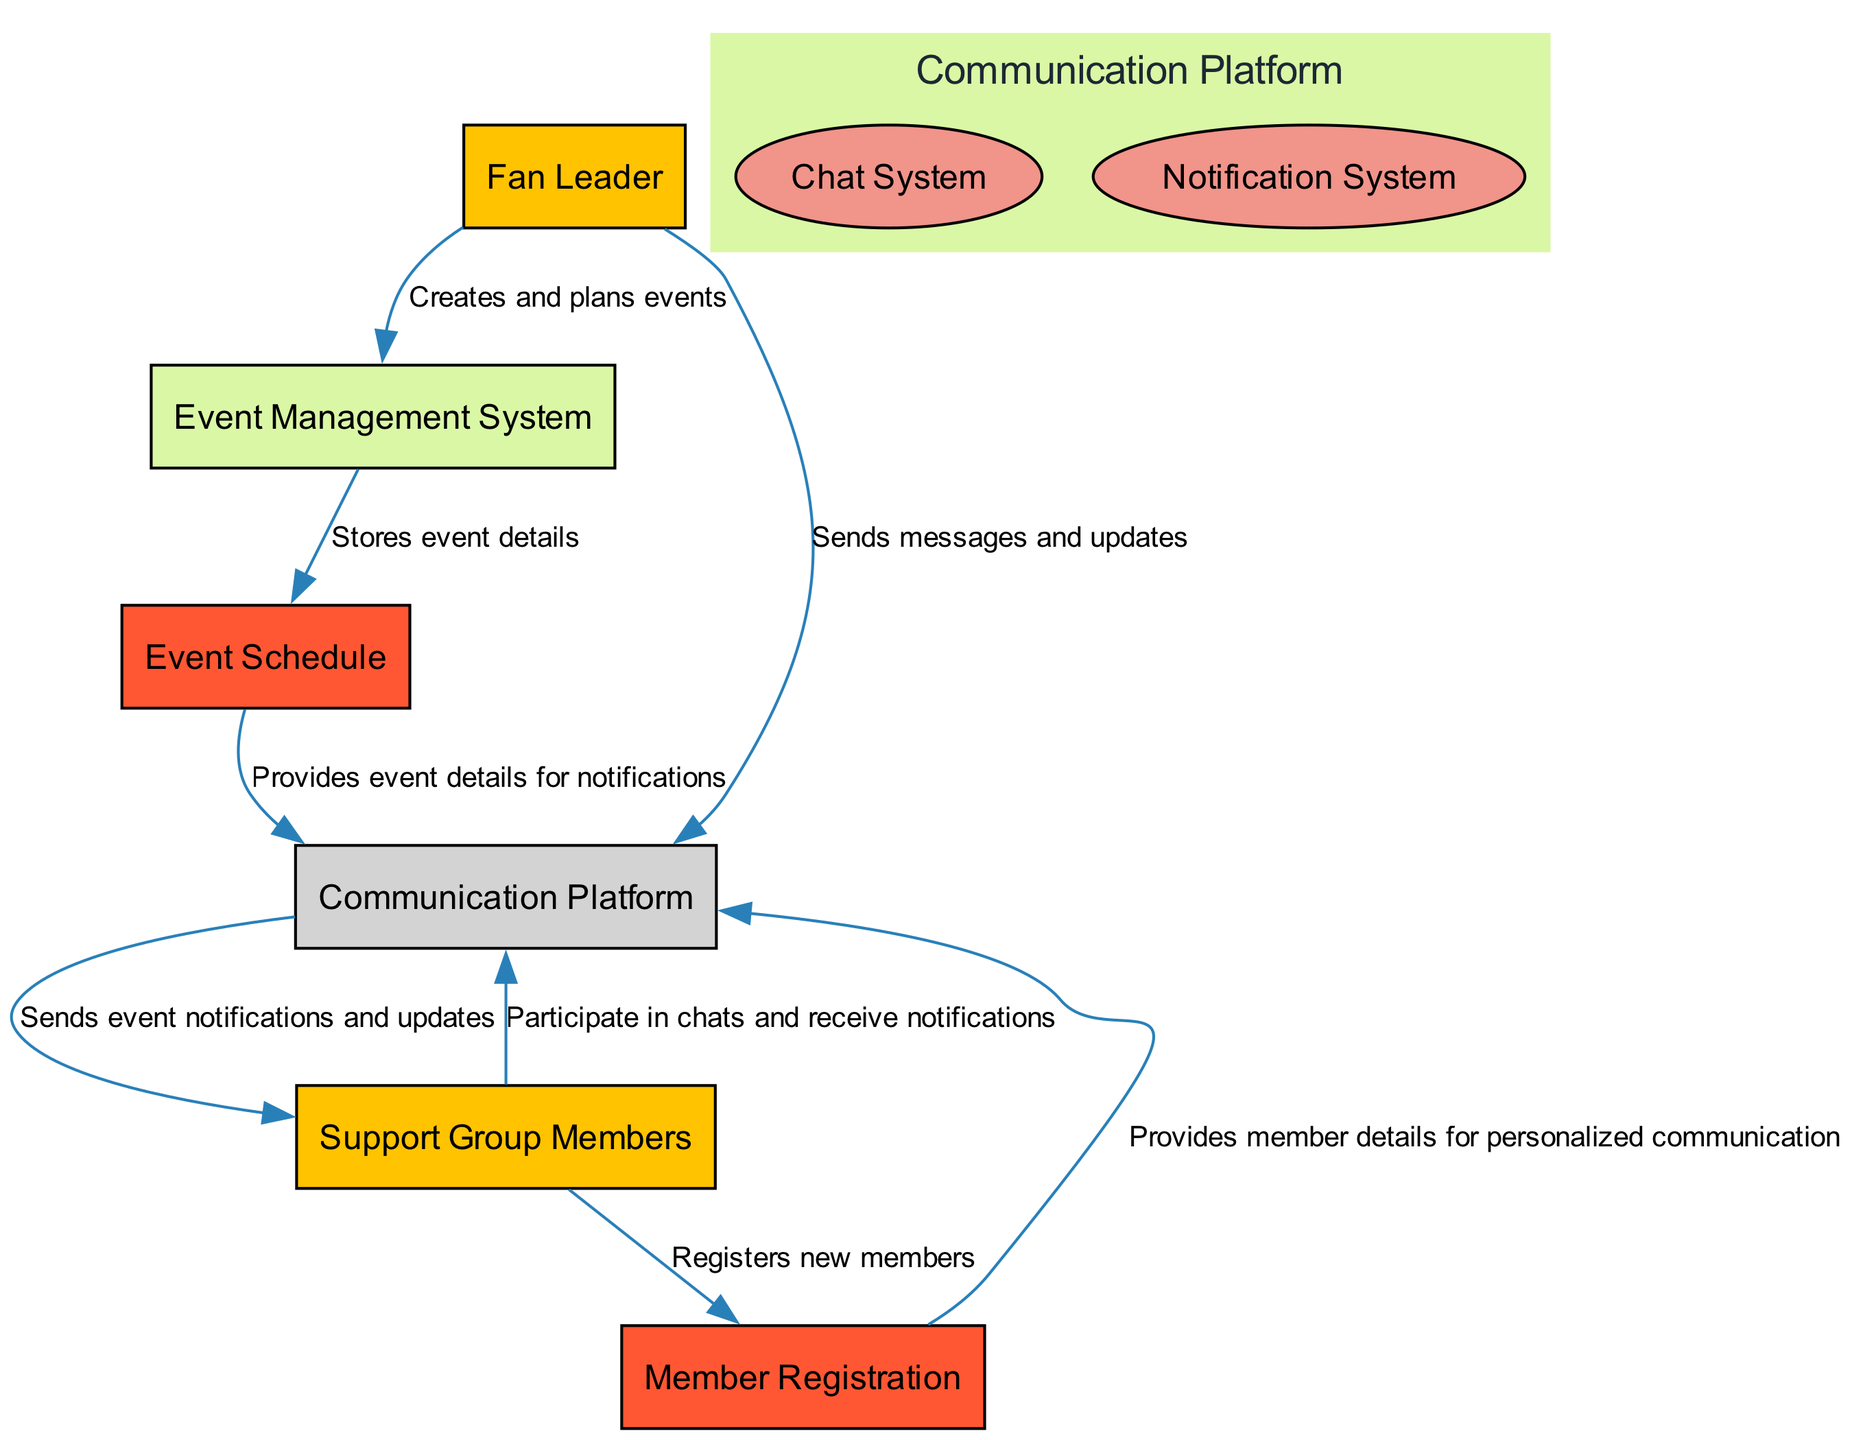What is the main role of the Fan Leader? The Fan Leader is defined as an external entity that organizes support activities and maintains communication with the members, indicating their primary responsibility is to lead and coordinate.
Answer: Organizes support activities How many data stores are in the diagram? The diagram features two data stores, namely the Event Schedule and Member Registration. Counting each identified data store reveals this total.
Answer: 2 Which process allows members to chat? The Chat System is a subprocess under the Communication Platform that explicitly allows members to engage in discussions and chat about events.
Answer: Chat System From which entity does the Notification System receive messages? The Notification System receives updates from the Communication Platform, which processes information from various sources, including the Fan Leader and Support Group Members.
Answer: Communication Platform What type of entity is the Event Management System? The Event Management System, as indicated in the diagram, is categorized as a process, responsible for planning and scheduling events for the support group.
Answer: Process How many edges are connected to the Support Group Members? Counting all direct connections to Support Group Members reveals that there are three edges connected to them, linking to both the Communication Platform and Member Registration.
Answer: 3 What does the Event Management System send to the Event Schedule? The Event Management System sends event details to the Event Schedule, where all the specifics of planned events are stored for easy reference.
Answer: Stores event details Who is responsible for creating and planning events? The Fan Leader is responsible for creating and planning events, as indicated by the direct flow of actions from the Fan Leader to the Event Management System.
Answer: Fan Leader What type of communication does the Communication Platform enable? The Communication Platform enables both chatting and notifications among members and fan leaders, thus providing a comprehensive channel for information sharing.
Answer: Chatting and notifications 